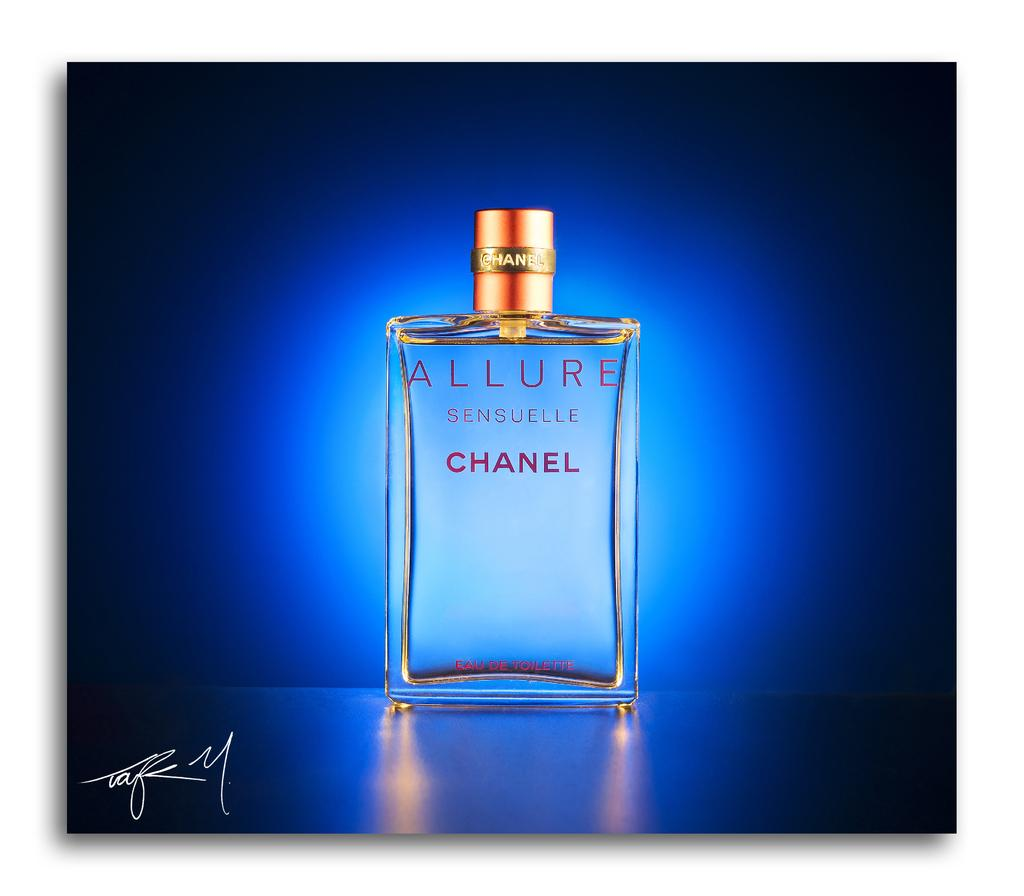<image>
Relay a brief, clear account of the picture shown. a bottle of Chanel Allure perfume with a blue background 